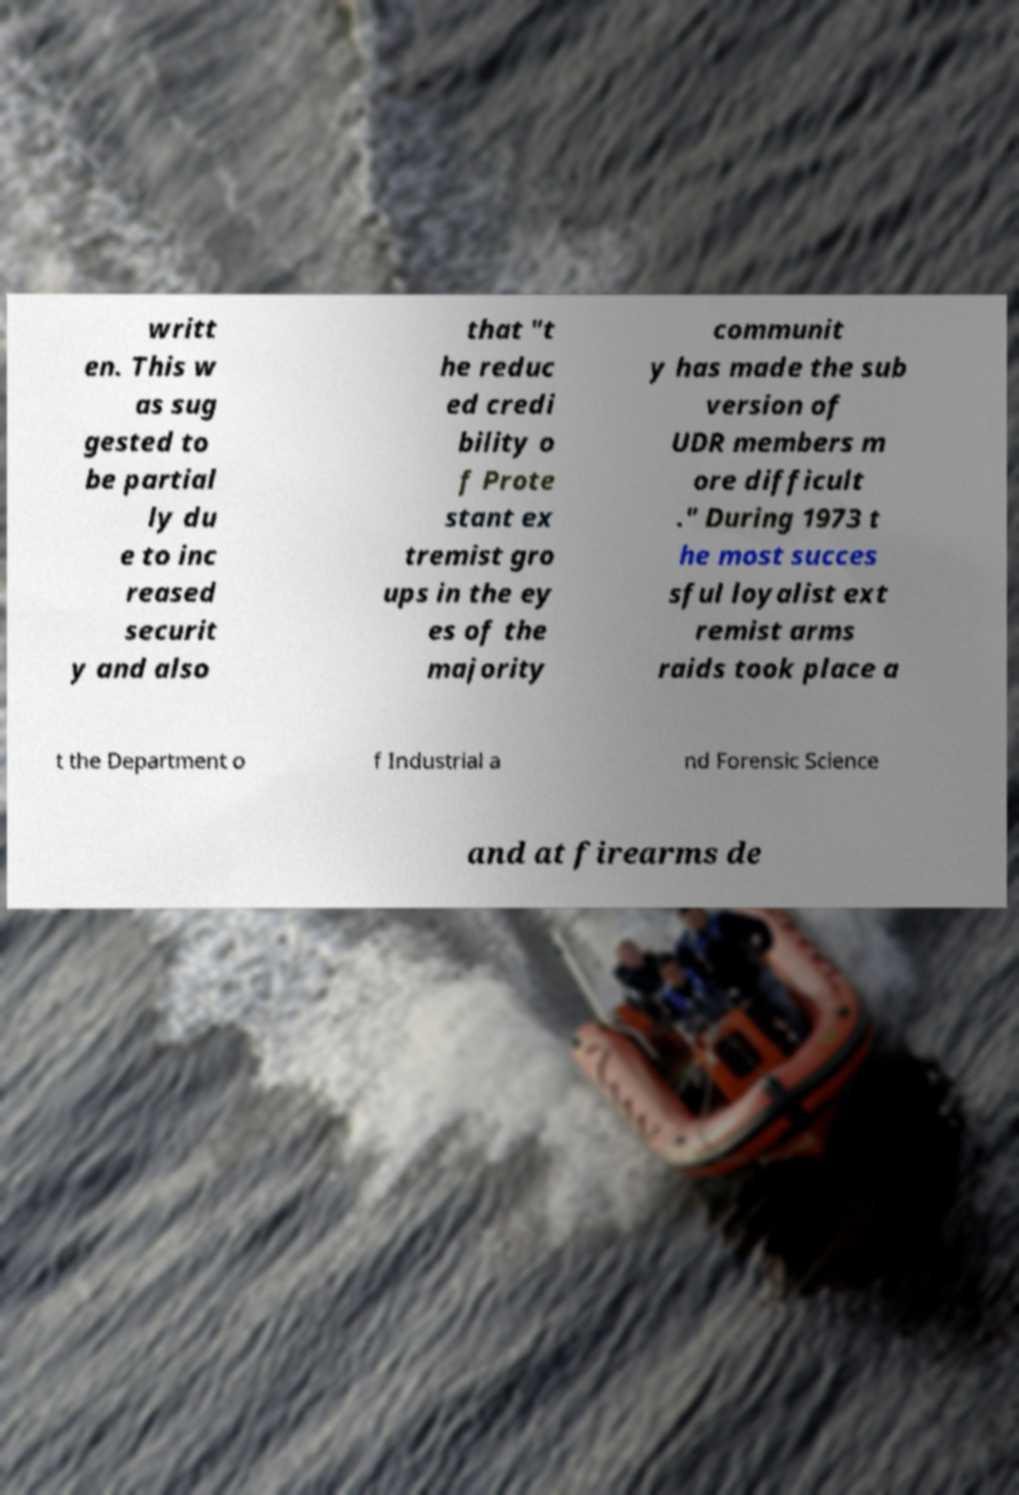For documentation purposes, I need the text within this image transcribed. Could you provide that? writt en. This w as sug gested to be partial ly du e to inc reased securit y and also that "t he reduc ed credi bility o f Prote stant ex tremist gro ups in the ey es of the majority communit y has made the sub version of UDR members m ore difficult ." During 1973 t he most succes sful loyalist ext remist arms raids took place a t the Department o f Industrial a nd Forensic Science and at firearms de 